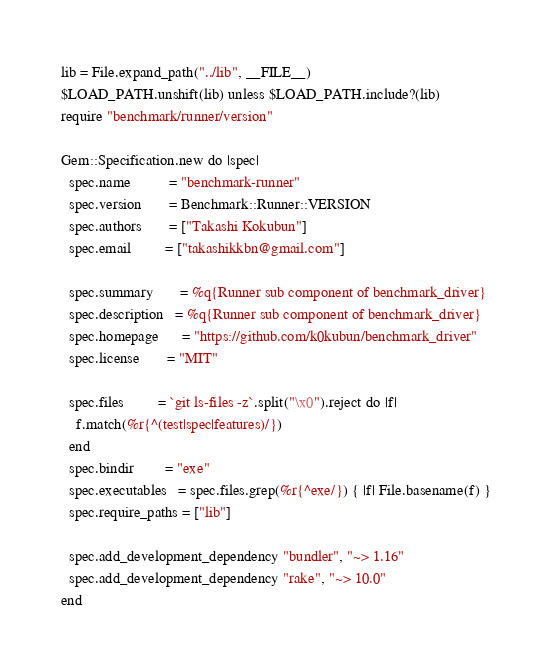Convert code to text. <code><loc_0><loc_0><loc_500><loc_500><_Ruby_>
lib = File.expand_path("../lib", __FILE__)
$LOAD_PATH.unshift(lib) unless $LOAD_PATH.include?(lib)
require "benchmark/runner/version"

Gem::Specification.new do |spec|
  spec.name          = "benchmark-runner"
  spec.version       = Benchmark::Runner::VERSION
  spec.authors       = ["Takashi Kokubun"]
  spec.email         = ["takashikkbn@gmail.com"]

  spec.summary       = %q{Runner sub component of benchmark_driver}
  spec.description   = %q{Runner sub component of benchmark_driver}
  spec.homepage      = "https://github.com/k0kubun/benchmark_driver"
  spec.license       = "MIT"

  spec.files         = `git ls-files -z`.split("\x0").reject do |f|
    f.match(%r{^(test|spec|features)/})
  end
  spec.bindir        = "exe"
  spec.executables   = spec.files.grep(%r{^exe/}) { |f| File.basename(f) }
  spec.require_paths = ["lib"]

  spec.add_development_dependency "bundler", "~> 1.16"
  spec.add_development_dependency "rake", "~> 10.0"
end
</code> 